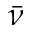<formula> <loc_0><loc_0><loc_500><loc_500>\bar { \nu }</formula> 